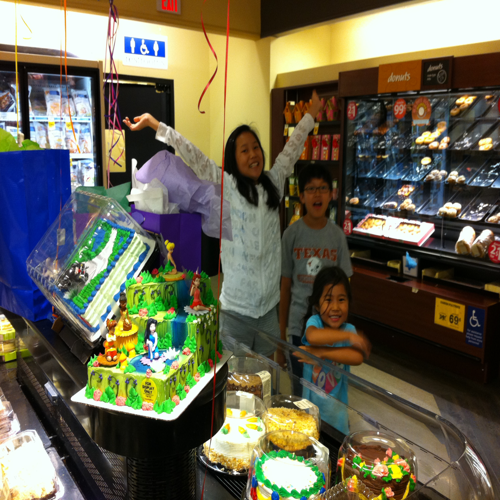Could you tell me what celebration is taking place here? Based on the cake with figurines and decorations, it seems like a birthday party or a themed celebration. The cake features a colorful design that appears to cater to a child's interests. 